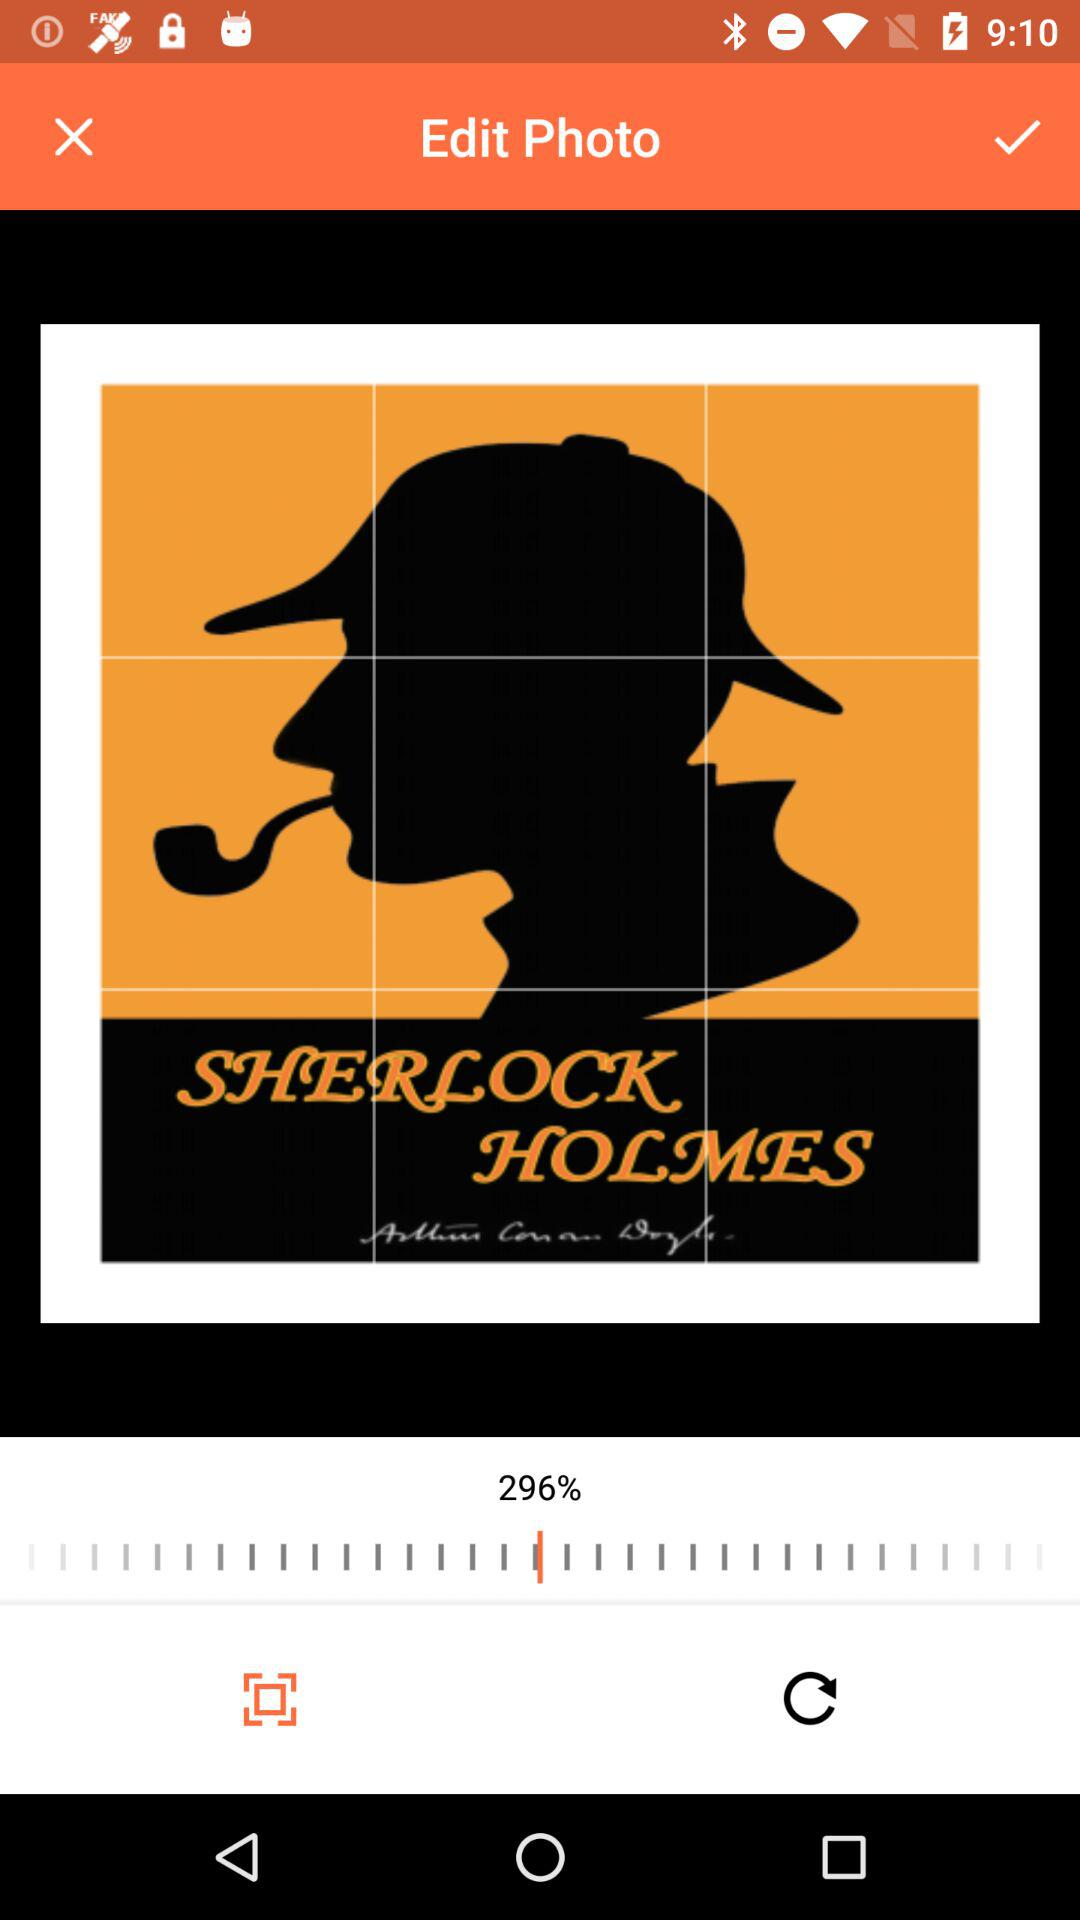What percentage was the photo adjusted to? The photo was adjusted to 296 percent. 